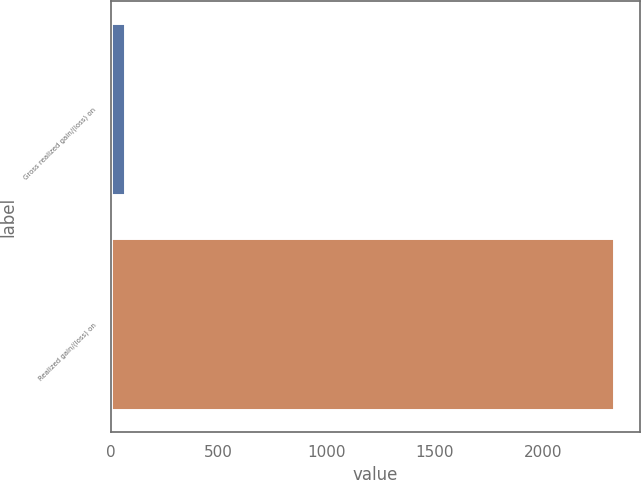Convert chart to OTSL. <chart><loc_0><loc_0><loc_500><loc_500><bar_chart><fcel>Gross realized gain/(loss) on<fcel>Realized gain/(loss) on<nl><fcel>66<fcel>2332<nl></chart> 